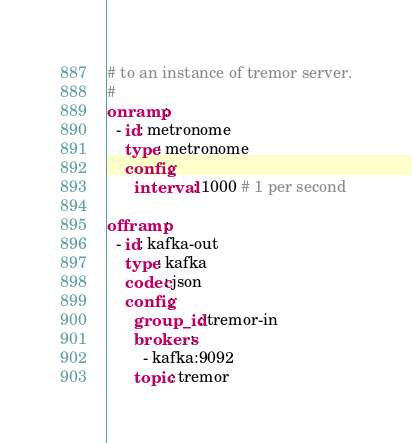Convert code to text. <code><loc_0><loc_0><loc_500><loc_500><_YAML_># to an instance of tremor server.
#
onramp:
  - id: metronome
    type: metronome
    config:
      interval: 1000 # 1 per second

offramp:
  - id: kafka-out
    type: kafka
    codec: json
    config:
      group_id: tremor-in
      brokers:
        - kafka:9092
      topic: tremor
</code> 